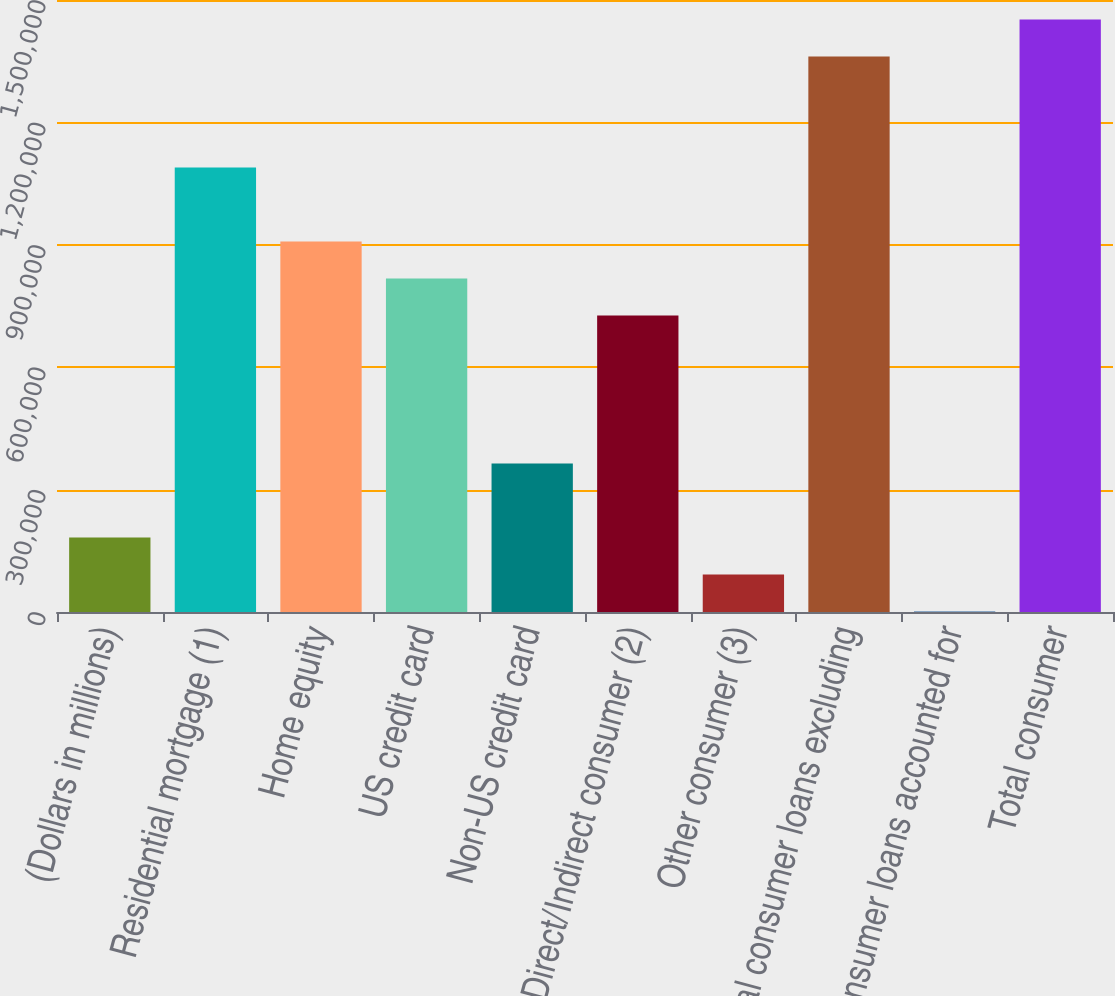<chart> <loc_0><loc_0><loc_500><loc_500><bar_chart><fcel>(Dollars in millions)<fcel>Residential mortgage (1)<fcel>Home equity<fcel>US credit card<fcel>Non-US credit card<fcel>Direct/Indirect consumer (2)<fcel>Other consumer (3)<fcel>Total consumer loans excluding<fcel>Consumer loans accounted for<fcel>Total consumer<nl><fcel>182368<fcel>1.08918e+06<fcel>907819<fcel>817138<fcel>363731<fcel>726456<fcel>91686.4<fcel>1.36123e+06<fcel>1005<fcel>1.45191e+06<nl></chart> 